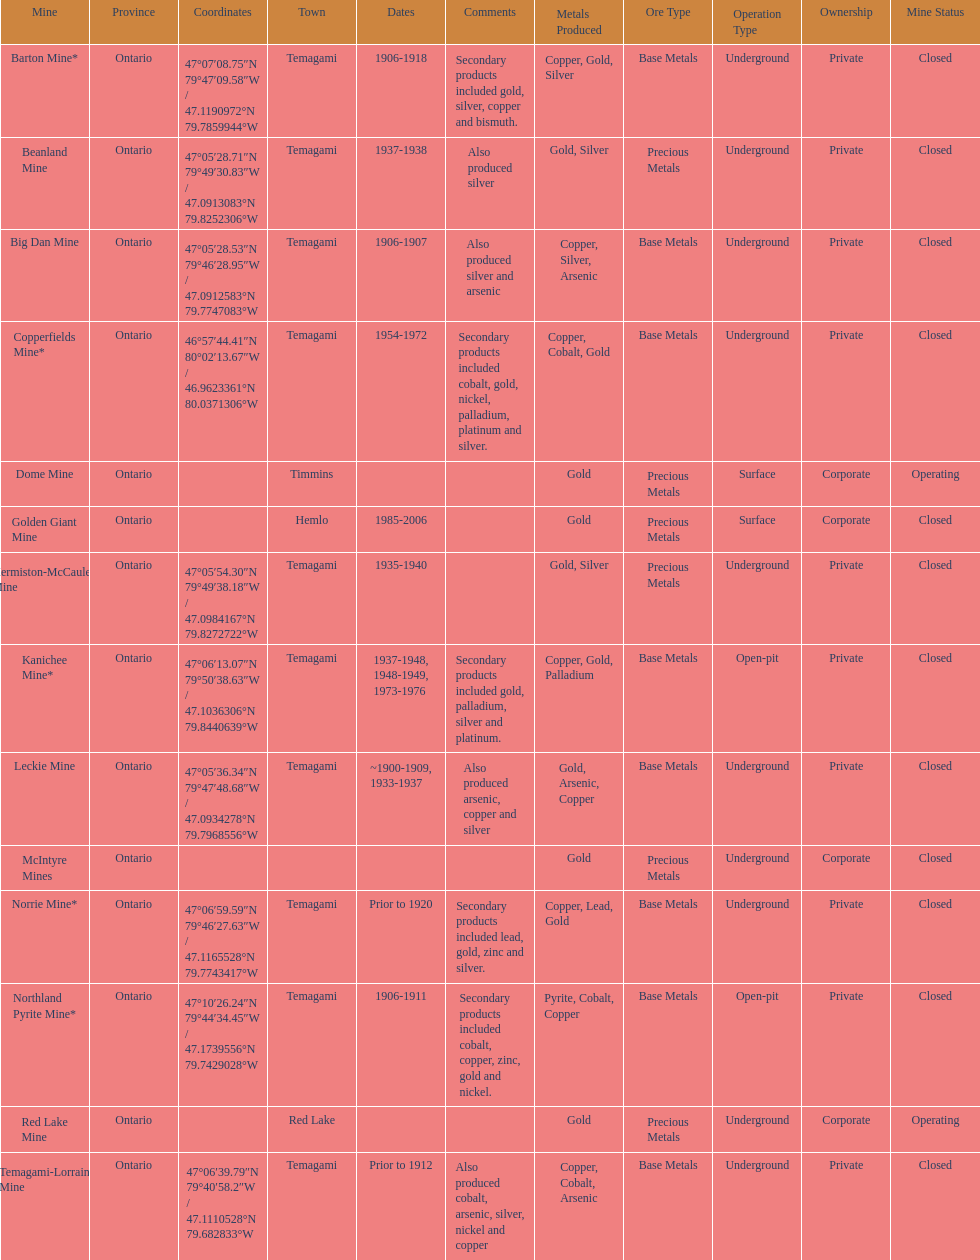What town is listed the most? Temagami. Could you parse the entire table? {'header': ['Mine', 'Province', 'Coordinates', 'Town', 'Dates', 'Comments', 'Metals Produced', 'Ore Type', 'Operation Type', 'Ownership', 'Mine Status'], 'rows': [['Barton Mine*', 'Ontario', '47°07′08.75″N 79°47′09.58″W\ufeff / \ufeff47.1190972°N 79.7859944°W', 'Temagami', '1906-1918', 'Secondary products included gold, silver, copper and bismuth.', 'Copper, Gold, Silver', 'Base Metals', 'Underground', 'Private', 'Closed'], ['Beanland Mine', 'Ontario', '47°05′28.71″N 79°49′30.83″W\ufeff / \ufeff47.0913083°N 79.8252306°W', 'Temagami', '1937-1938', 'Also produced silver', 'Gold, Silver', 'Precious Metals', 'Underground', 'Private', 'Closed'], ['Big Dan Mine', 'Ontario', '47°05′28.53″N 79°46′28.95″W\ufeff / \ufeff47.0912583°N 79.7747083°W', 'Temagami', '1906-1907', 'Also produced silver and arsenic', 'Copper, Silver, Arsenic', 'Base Metals', 'Underground', 'Private', 'Closed'], ['Copperfields Mine*', 'Ontario', '46°57′44.41″N 80°02′13.67″W\ufeff / \ufeff46.9623361°N 80.0371306°W', 'Temagami', '1954-1972', 'Secondary products included cobalt, gold, nickel, palladium, platinum and silver.', 'Copper, Cobalt, Gold', 'Base Metals', 'Underground', 'Private', 'Closed'], ['Dome Mine', 'Ontario', '', 'Timmins', '', '', 'Gold', 'Precious Metals', 'Surface', 'Corporate', 'Operating'], ['Golden Giant Mine', 'Ontario', '', 'Hemlo', '1985-2006', '', 'Gold', 'Precious Metals', 'Surface', 'Corporate', 'Closed'], ['Hermiston-McCauley Mine', 'Ontario', '47°05′54.30″N 79°49′38.18″W\ufeff / \ufeff47.0984167°N 79.8272722°W', 'Temagami', '1935-1940', '', 'Gold, Silver', 'Precious Metals', 'Underground', 'Private', 'Closed'], ['Kanichee Mine*', 'Ontario', '47°06′13.07″N 79°50′38.63″W\ufeff / \ufeff47.1036306°N 79.8440639°W', 'Temagami', '1937-1948, 1948-1949, 1973-1976', 'Secondary products included gold, palladium, silver and platinum.', 'Copper, Gold, Palladium', 'Base Metals', 'Open-pit', 'Private', 'Closed'], ['Leckie Mine', 'Ontario', '47°05′36.34″N 79°47′48.68″W\ufeff / \ufeff47.0934278°N 79.7968556°W', 'Temagami', '~1900-1909, 1933-1937', 'Also produced arsenic, copper and silver', 'Gold, Arsenic, Copper', 'Base Metals', 'Underground', 'Private', 'Closed'], ['McIntyre Mines', 'Ontario', '', '', '', '', 'Gold', 'Precious Metals', 'Underground', 'Corporate', 'Closed'], ['Norrie Mine*', 'Ontario', '47°06′59.59″N 79°46′27.63″W\ufeff / \ufeff47.1165528°N 79.7743417°W', 'Temagami', 'Prior to 1920', 'Secondary products included lead, gold, zinc and silver.', 'Copper, Lead, Gold', 'Base Metals', 'Underground', 'Private', 'Closed'], ['Northland Pyrite Mine*', 'Ontario', '47°10′26.24″N 79°44′34.45″W\ufeff / \ufeff47.1739556°N 79.7429028°W', 'Temagami', '1906-1911', 'Secondary products included cobalt, copper, zinc, gold and nickel.', 'Pyrite, Cobalt, Copper', 'Base Metals', 'Open-pit', 'Private', 'Closed'], ['Red Lake Mine', 'Ontario', '', 'Red Lake', '', '', 'Gold', 'Precious Metals', 'Underground', 'Corporate', 'Operating'], ['Temagami-Lorrain Mine', 'Ontario', '47°06′39.79″N 79°40′58.2″W\ufeff / \ufeff47.1110528°N 79.682833°W', 'Temagami', 'Prior to 1912', 'Also produced cobalt, arsenic, silver, nickel and copper', 'Copper, Cobalt, Arsenic', 'Base Metals', 'Underground', 'Private', 'Closed']]} 